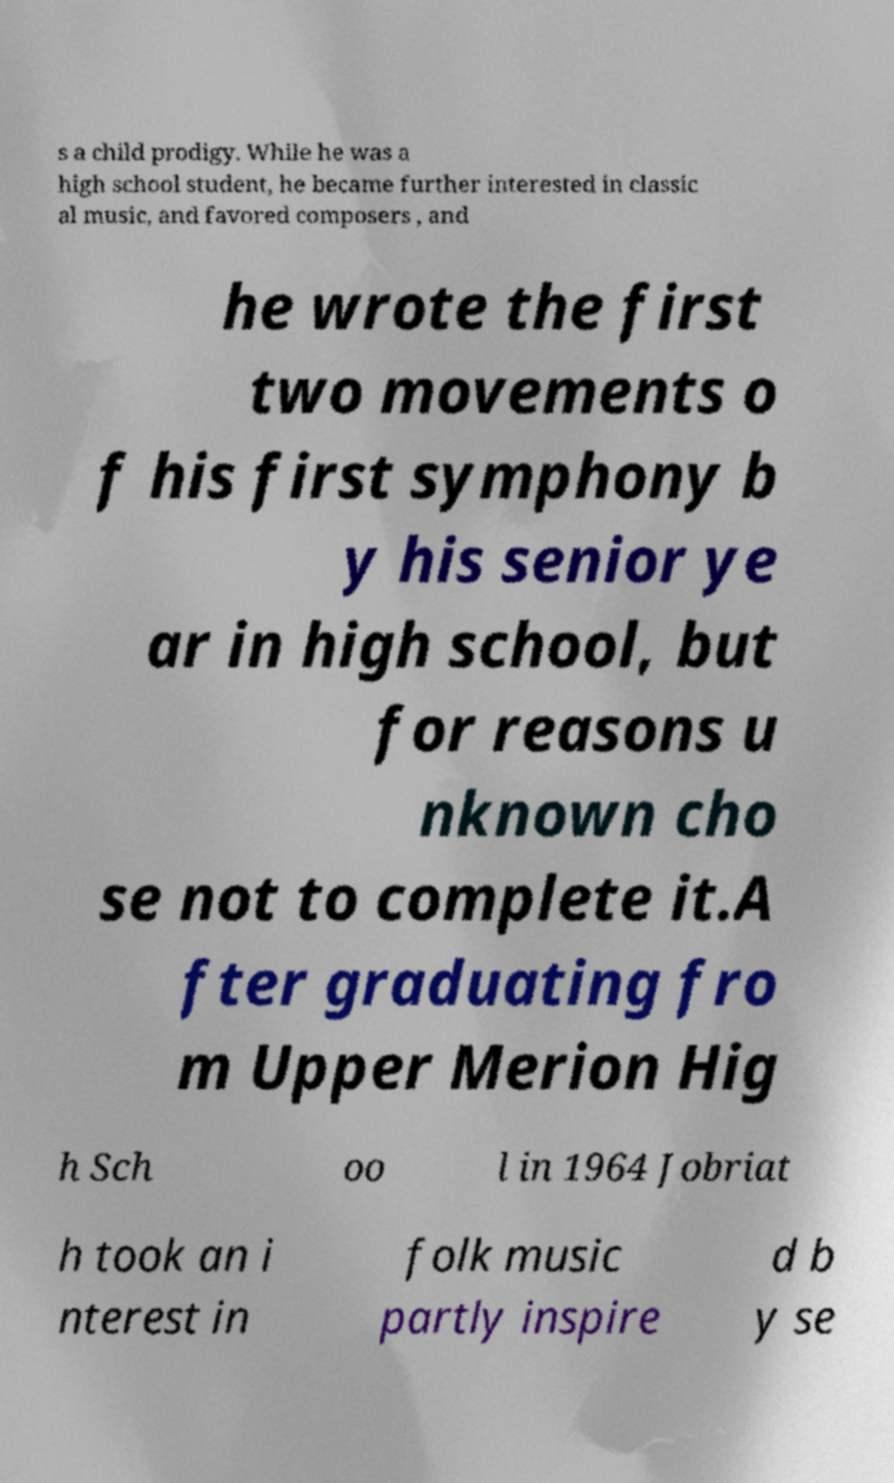For documentation purposes, I need the text within this image transcribed. Could you provide that? s a child prodigy. While he was a high school student, he became further interested in classic al music, and favored composers , and he wrote the first two movements o f his first symphony b y his senior ye ar in high school, but for reasons u nknown cho se not to complete it.A fter graduating fro m Upper Merion Hig h Sch oo l in 1964 Jobriat h took an i nterest in folk music partly inspire d b y se 